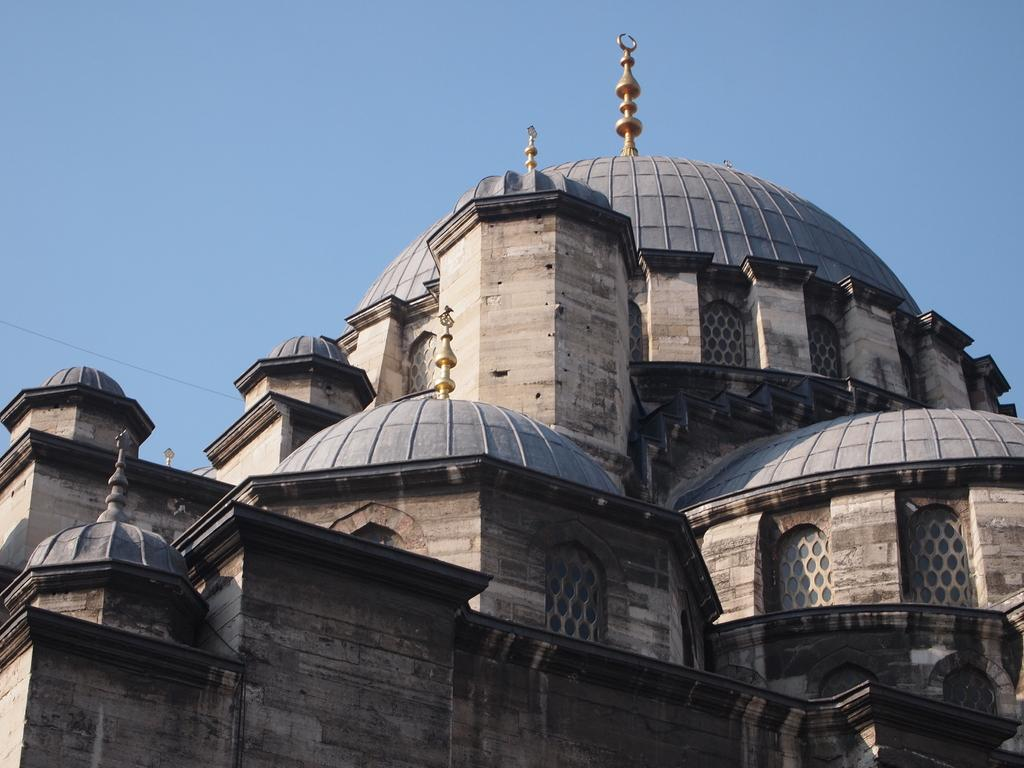What type of structure can be seen in the image? There is an architectural structure in the image. What else is present in the image besides the structure? There is a wire in the image. What can be seen in the background of the image? The sky is visible in the background of the image. What scent can be detected coming from the structure in the image? There is no information about a scent in the image, as it focuses on the visual aspects of the structure and wire. 